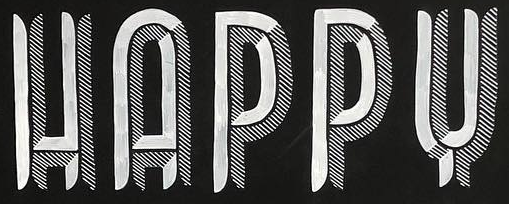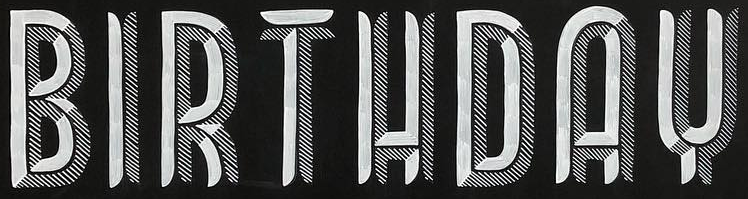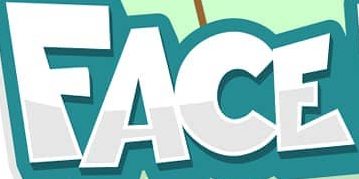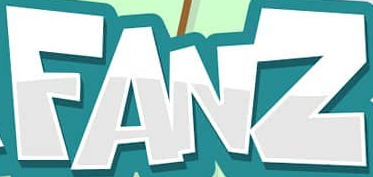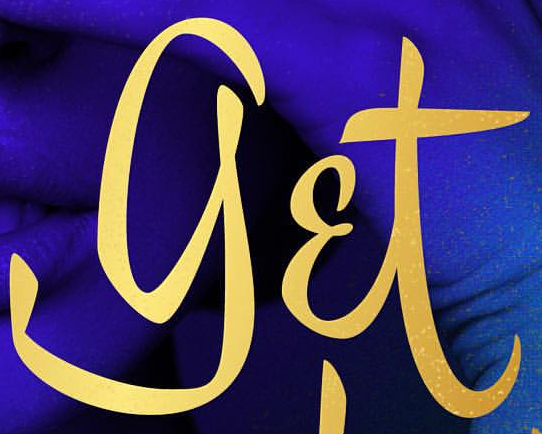Identify the words shown in these images in order, separated by a semicolon. HAPPY; BIRTHDAY; FACE; FANZ; get 